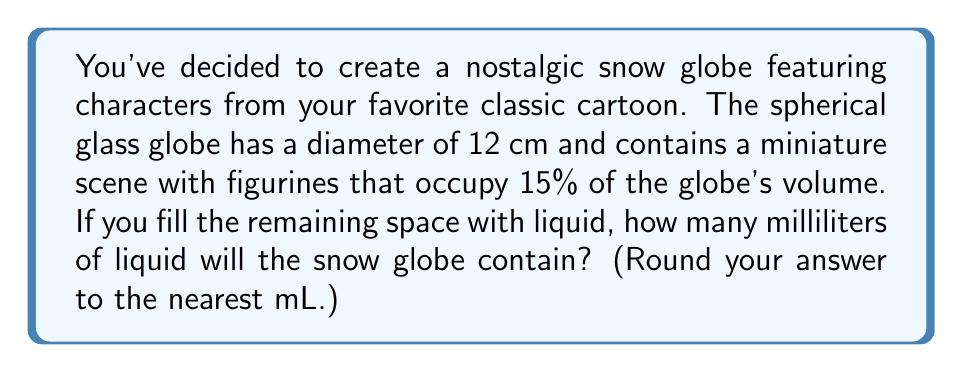Help me with this question. Let's approach this step-by-step:

1) First, we need to calculate the volume of the entire spherical snow globe. The formula for the volume of a sphere is:

   $$V = \frac{4}{3}\pi r^3$$

   where $r$ is the radius of the sphere.

2) The diameter is 12 cm, so the radius is 6 cm. Let's substitute this into our formula:

   $$V = \frac{4}{3}\pi (6\text{ cm})^3 = \frac{4}{3}\pi (216\text{ cm}^3) = 288\pi\text{ cm}^3$$

3) Now, let's calculate this:

   $$288\pi \approx 904.78\text{ cm}^3$$

4) However, 15% of this volume is occupied by the figurines. We need to find 85% of this volume:

   $$904.78 \times 0.85 = 769.06\text{ cm}^3$$

5) Finally, we need to convert this to milliliters. Fortunately, 1 cm³ = 1 mL, so our answer in milliliters is the same number:

   $$769.06\text{ mL}$$

6) Rounding to the nearest mL:

   $$769\text{ mL}$$
Answer: 769 mL 